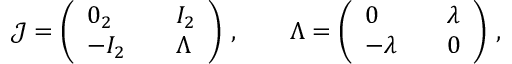<formula> <loc_0><loc_0><loc_500><loc_500>\begin{array} { r } { { \mathcal { J } } = \left ( \begin{array} { l l l } { 0 _ { 2 } } & { I _ { 2 } } \\ { - I _ { 2 } } & { \Lambda } \end{array} \right ) \, , \quad \Lambda = \left ( \begin{array} { l l l } { 0 } & { \lambda } \\ { - \lambda } & { 0 } \end{array} \right ) \, , } \end{array}</formula> 